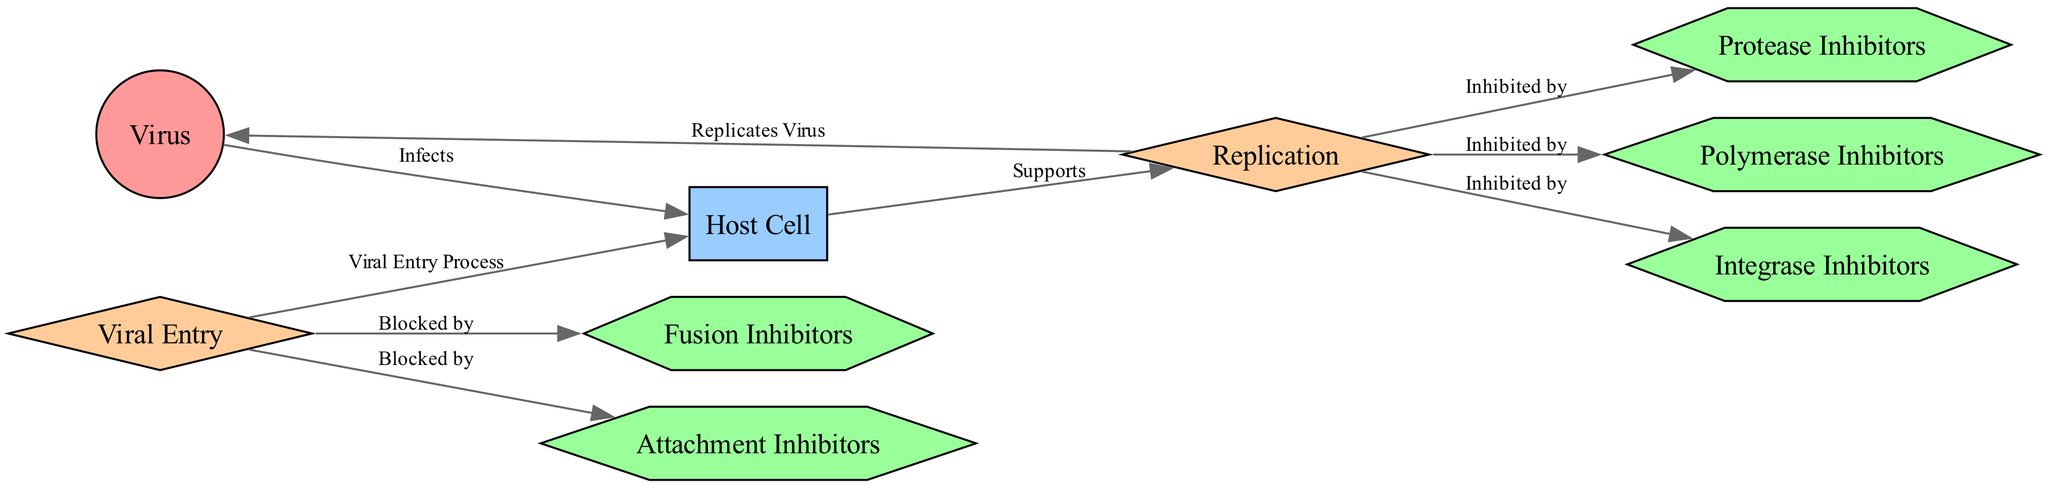What type of node is "Virus"? The node labeled "Virus" is categorized as a "pathogen" in the diagram according to the node type definitions.
Answer: pathogen How many edges are in the diagram? By counting all connections (arrows) between nodes in the diagram, I see there are 8 edges listed in the data.
Answer: 8 What is the relationship between "Virus" and "Host Cell"? The diagram indicates that the "Virus" infects the "Host Cell," illustrated by the connection labeled "Infects."
Answer: Infects Which drug blocks viral entry? The diagram specifically connects "Viral Entry" with both "Attachment Inhibitors" and "Fusion Inhibitors," indicating that these drugs block the entry process.
Answer: Attachment Inhibitors What processes does "Replication" support? The "Replication" process is supported by the "Host Cell," which is indicated by the directed edge labeled "Supports" connecting them in the diagram.
Answer: Host Cell Which drugs are labeled as inhibiting the replication process? The drugs listed as inhibiting "Replication" in the diagram are "Protease Inhibitors," "Polymerase Inhibitors," and "Integrase Inhibitors," as denoted by their connections to the replication node.
Answer: Protease Inhibitors, Polymerase Inhibitors, Integrase Inhibitors How many drug types are represented in the diagram? Counting each distinct drug node (Attachment Inhibitors, Fusion Inhibitors, Protease Inhibitors, Polymerase Inhibitors, and Integrase Inhibitors) reveals there are a total of 5 drug types in the diagram.
Answer: 5 Which process is linked to "Viral Entry"? "Viral Entry" connects directly to the "Host Cell," as indicated by the edge labeled "Viral Entry Process," which shows the entry into host cells.
Answer: Host Cell What does "Replication" do to the "Virus"? According to the diagram, the process of "Replication" replicates the "Virus," as shown by the edge labeled "Replicates Virus."
Answer: Replicates Virus 